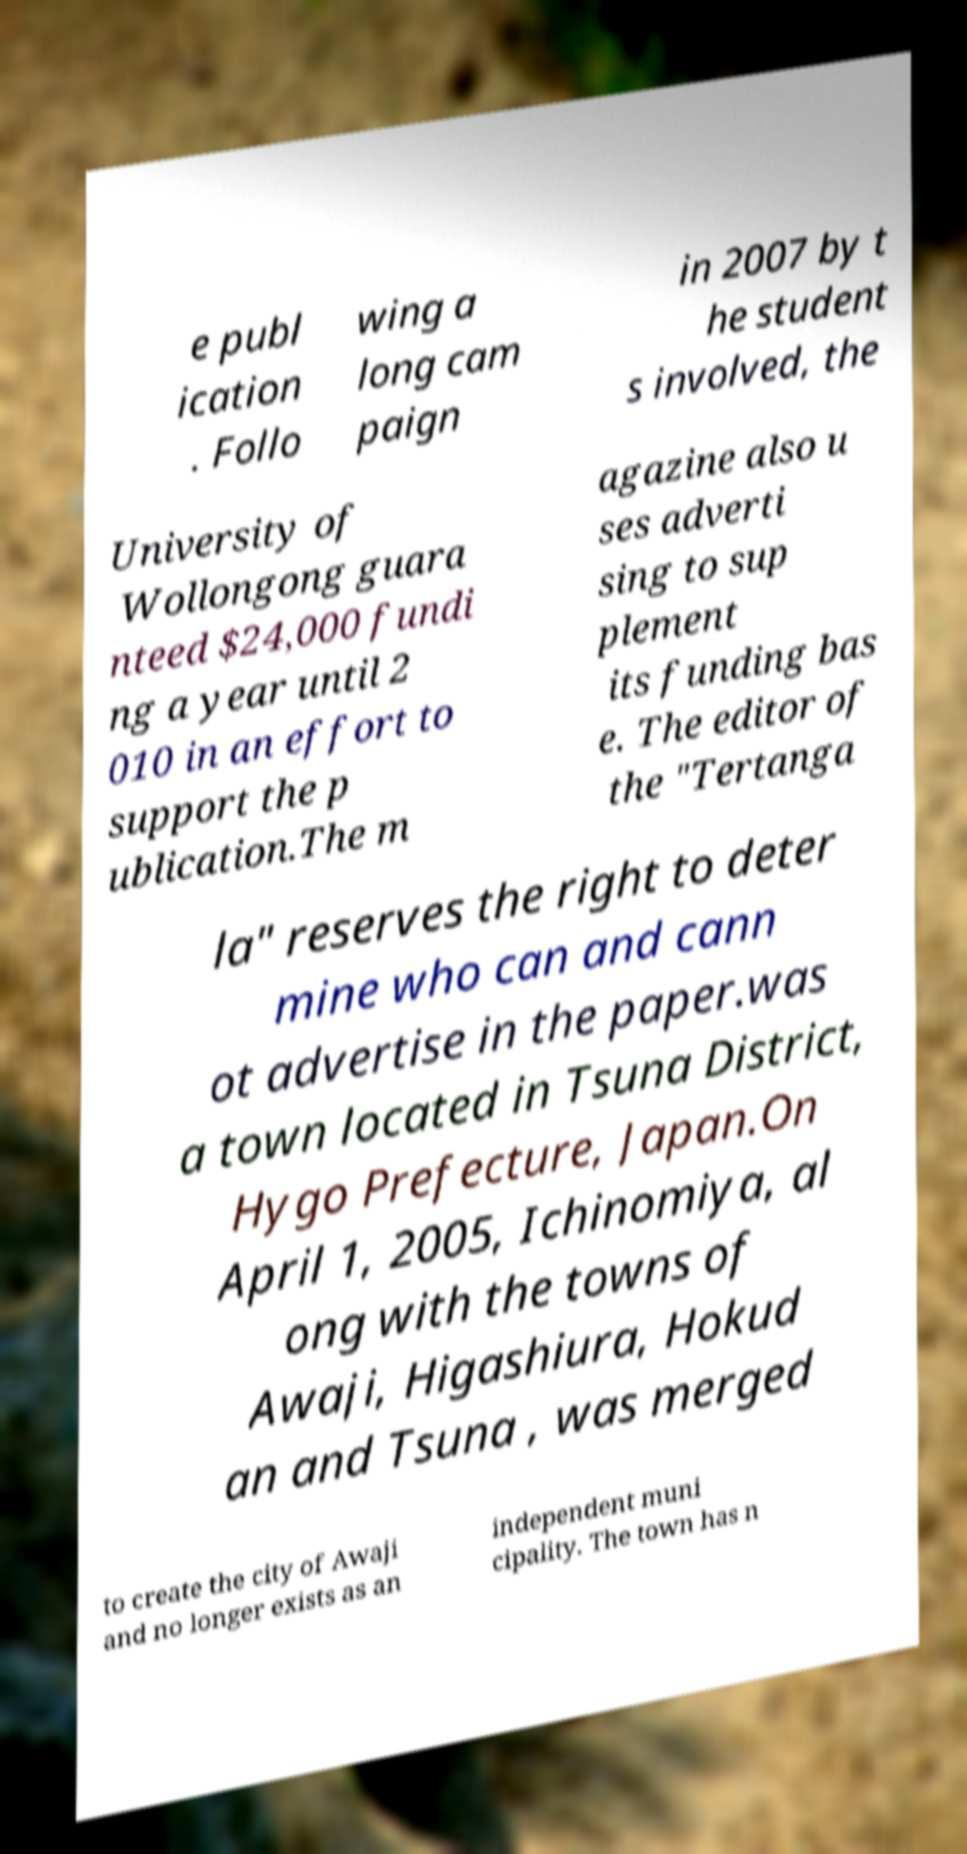Could you assist in decoding the text presented in this image and type it out clearly? e publ ication . Follo wing a long cam paign in 2007 by t he student s involved, the University of Wollongong guara nteed $24,000 fundi ng a year until 2 010 in an effort to support the p ublication.The m agazine also u ses adverti sing to sup plement its funding bas e. The editor of the "Tertanga la" reserves the right to deter mine who can and cann ot advertise in the paper.was a town located in Tsuna District, Hygo Prefecture, Japan.On April 1, 2005, Ichinomiya, al ong with the towns of Awaji, Higashiura, Hokud an and Tsuna , was merged to create the city of Awaji and no longer exists as an independent muni cipality. The town has n 